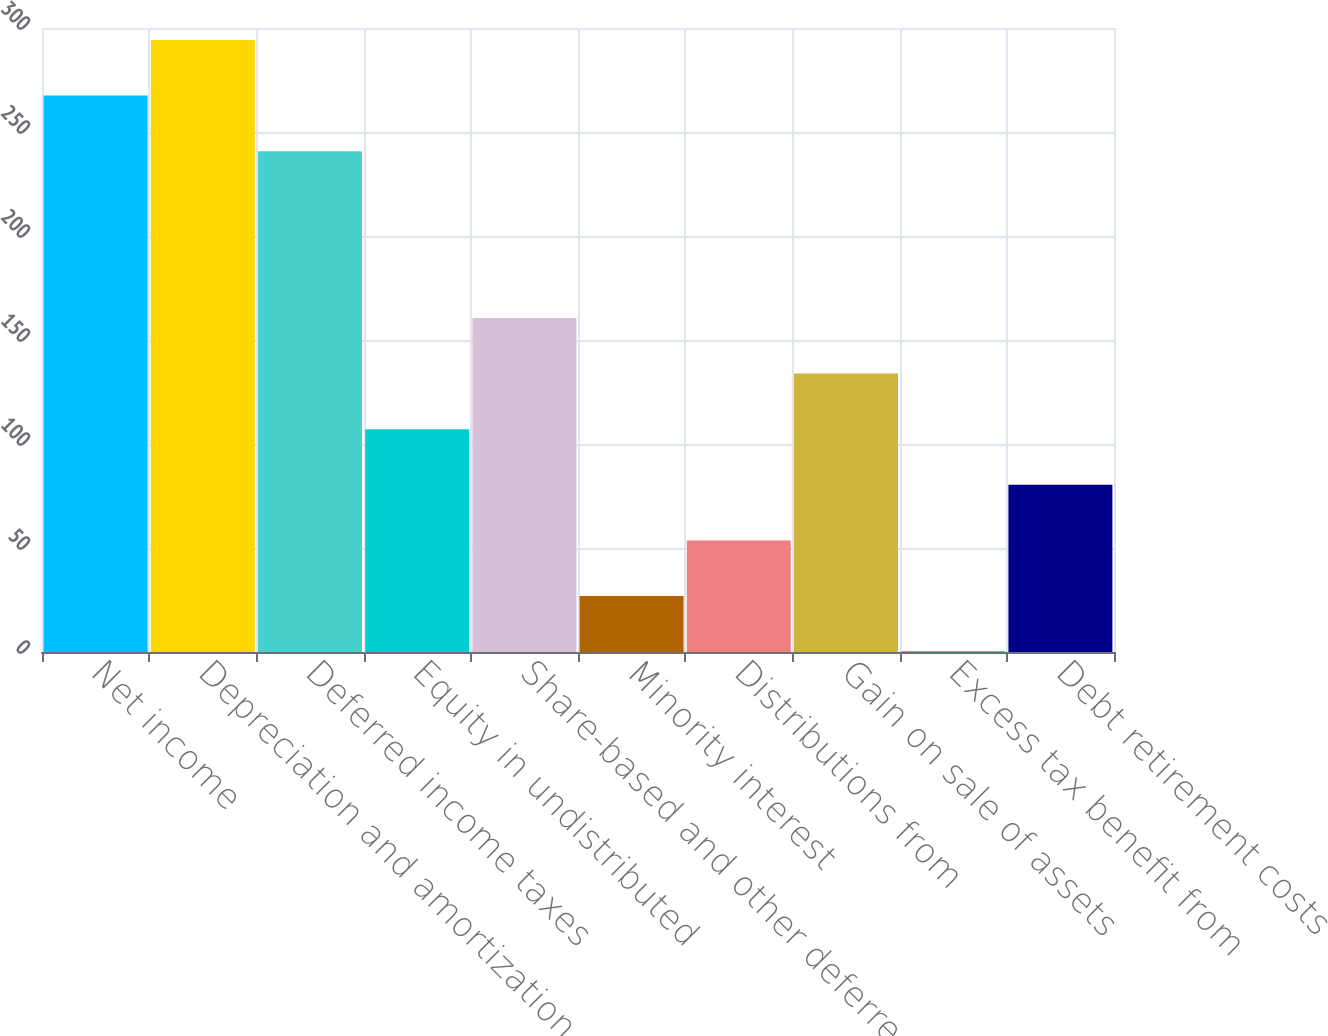<chart> <loc_0><loc_0><loc_500><loc_500><bar_chart><fcel>Net income<fcel>Depreciation and amortization<fcel>Deferred income taxes<fcel>Equity in undistributed<fcel>Share-based and other deferred<fcel>Minority interest<fcel>Distributions from<fcel>Gain on sale of assets<fcel>Excess tax benefit from<fcel>Debt retirement costs<nl><fcel>267.5<fcel>294.23<fcel>240.77<fcel>107.12<fcel>160.58<fcel>26.93<fcel>53.66<fcel>133.85<fcel>0.2<fcel>80.39<nl></chart> 